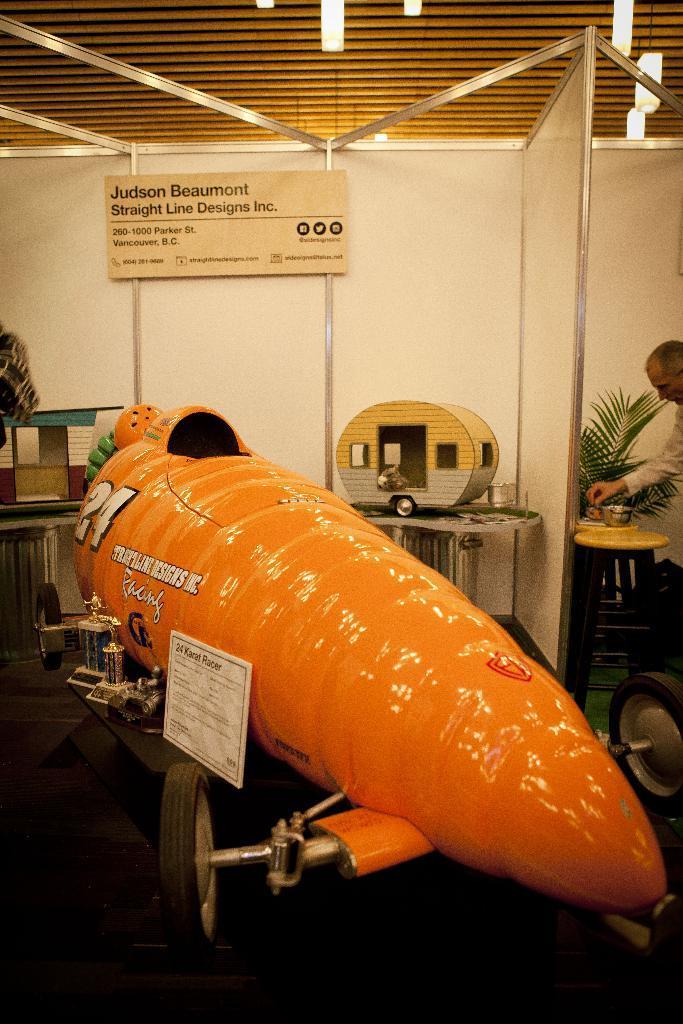How would you summarize this image in a sentence or two? In this image, we can see a vehicle which is colored orange. There is a board on the wall. There is an object in the middle of the image. There is a person, stool and plant on the right side of the image. 